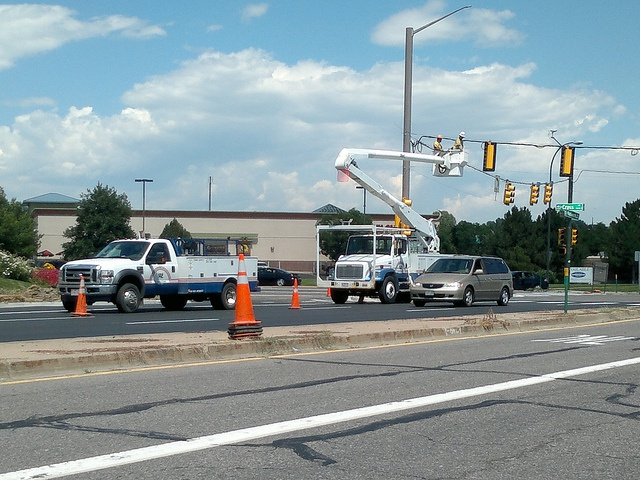Describe the objects in this image and their specific colors. I can see truck in lightblue, lightgray, black, darkgray, and gray tones, truck in lightblue, black, white, gray, and darkgray tones, car in lightblue, black, gray, darkgray, and darkblue tones, car in lightblue, black, gray, navy, and blue tones, and car in lightblue, black, gray, teal, and darkgreen tones in this image. 